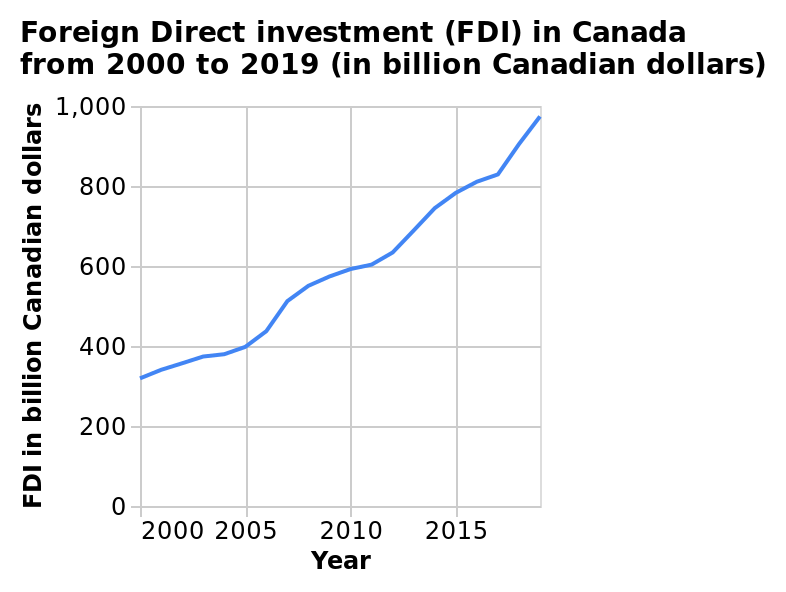<image>
How long did the biggest increase in investment last?  The biggest increase in investment lasted from 2010 until 2019. 